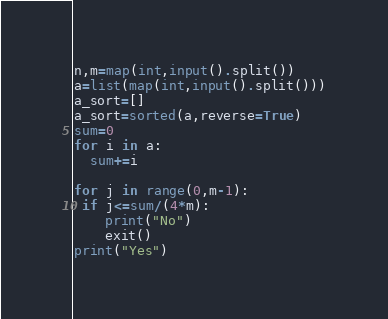<code> <loc_0><loc_0><loc_500><loc_500><_Python_>n,m=map(int,input().split())
a=list(map(int,input().split()))
a_sort=[]
a_sort=sorted(a,reverse=True)
sum=0
for i in a:
  sum+=i

for j in range(0,m-1):
 if j<=sum/(4*m):
    print("No")
    exit()
print("Yes")</code> 